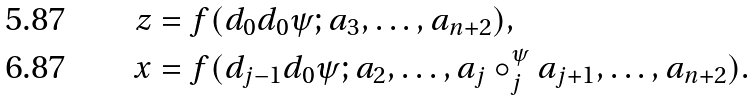<formula> <loc_0><loc_0><loc_500><loc_500>z & = f ( d _ { 0 } d _ { 0 } \psi ; a _ { 3 } , \dots , a _ { n + 2 } ) , \\ x & = f ( d _ { j - 1 } d _ { 0 } \psi ; a _ { 2 } , \dots , a _ { j } \circ ^ { \psi } _ { j } a _ { j + 1 } , \dots , a _ { n + 2 } ) .</formula> 